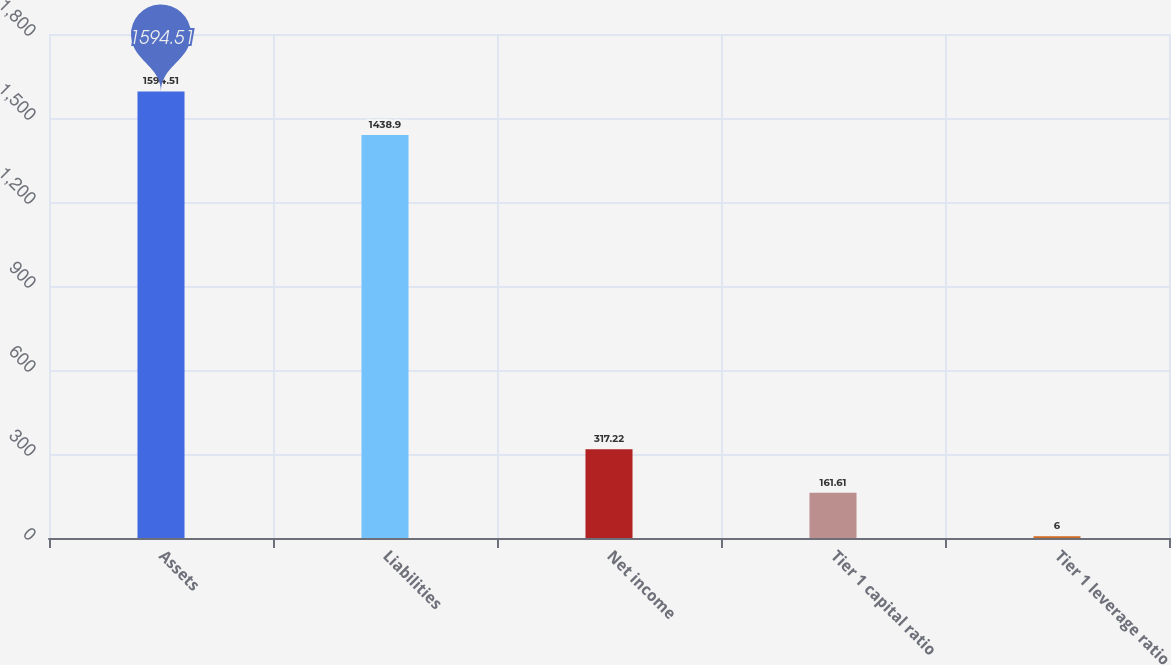<chart> <loc_0><loc_0><loc_500><loc_500><bar_chart><fcel>Assets<fcel>Liabilities<fcel>Net income<fcel>Tier 1 capital ratio<fcel>Tier 1 leverage ratio<nl><fcel>1594.51<fcel>1438.9<fcel>317.22<fcel>161.61<fcel>6<nl></chart> 